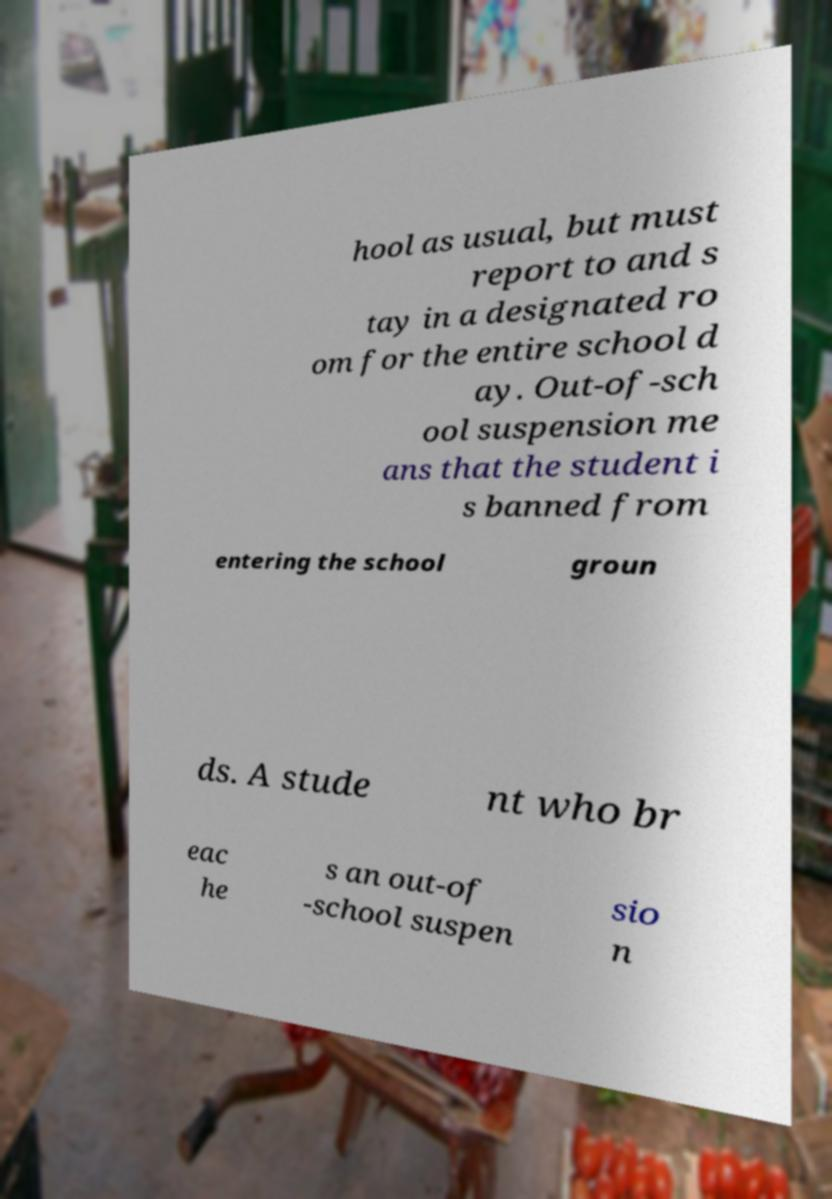I need the written content from this picture converted into text. Can you do that? hool as usual, but must report to and s tay in a designated ro om for the entire school d ay. Out-of-sch ool suspension me ans that the student i s banned from entering the school groun ds. A stude nt who br eac he s an out-of -school suspen sio n 